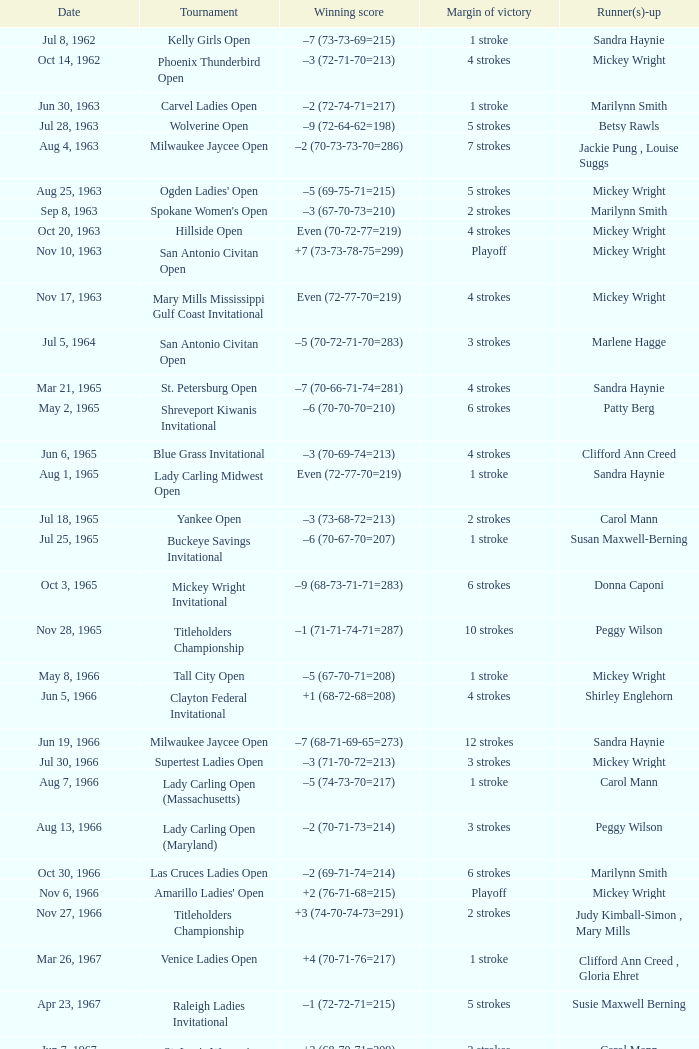What was the winning score when there were 9 strokes advantage? –7 (73-68-73-67=281). 